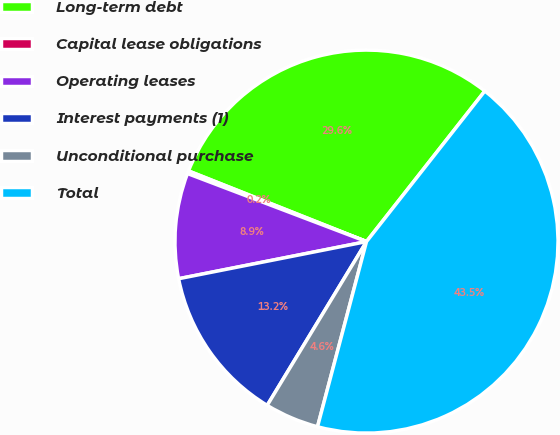Convert chart to OTSL. <chart><loc_0><loc_0><loc_500><loc_500><pie_chart><fcel>Long-term debt<fcel>Capital lease obligations<fcel>Operating leases<fcel>Interest payments (1)<fcel>Unconditional purchase<fcel>Total<nl><fcel>29.59%<fcel>0.23%<fcel>8.89%<fcel>13.22%<fcel>4.56%<fcel>43.52%<nl></chart> 